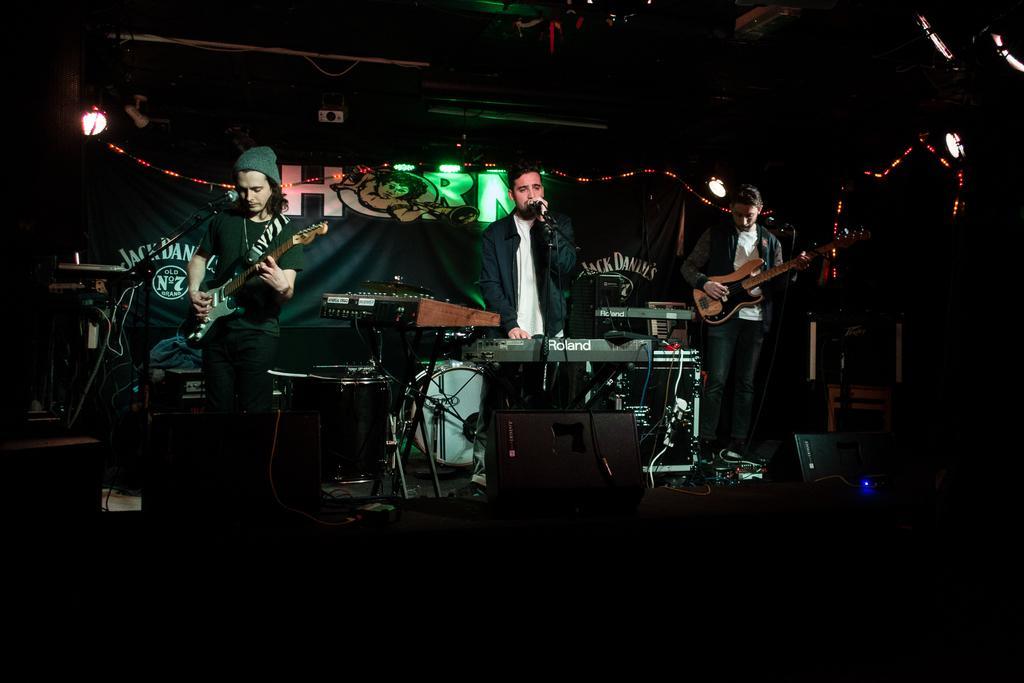Could you give a brief overview of what you see in this image? Three peoples are standing near the music players. At the background, we can see a banner, lights, projector. 